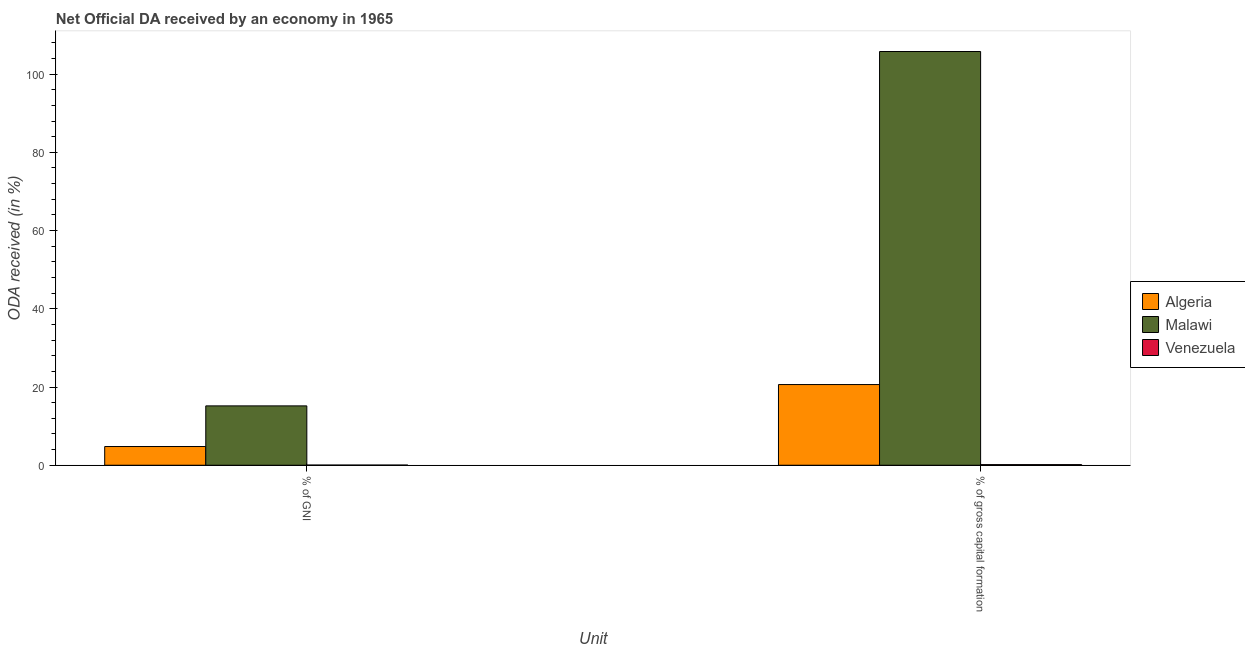Are the number of bars per tick equal to the number of legend labels?
Give a very brief answer. Yes. Are the number of bars on each tick of the X-axis equal?
Give a very brief answer. Yes. How many bars are there on the 2nd tick from the right?
Ensure brevity in your answer.  3. What is the label of the 1st group of bars from the left?
Ensure brevity in your answer.  % of GNI. What is the oda received as percentage of gni in Venezuela?
Your answer should be compact. 0.04. Across all countries, what is the maximum oda received as percentage of gni?
Offer a terse response. 15.18. Across all countries, what is the minimum oda received as percentage of gni?
Provide a short and direct response. 0.04. In which country was the oda received as percentage of gni maximum?
Your answer should be very brief. Malawi. In which country was the oda received as percentage of gross capital formation minimum?
Provide a succinct answer. Venezuela. What is the total oda received as percentage of gross capital formation in the graph?
Provide a short and direct response. 126.56. What is the difference between the oda received as percentage of gni in Algeria and that in Malawi?
Ensure brevity in your answer.  -10.39. What is the difference between the oda received as percentage of gni in Malawi and the oda received as percentage of gross capital formation in Venezuela?
Offer a very short reply. 15.02. What is the average oda received as percentage of gni per country?
Your response must be concise. 6.67. What is the difference between the oda received as percentage of gross capital formation and oda received as percentage of gni in Algeria?
Your response must be concise. 15.84. In how many countries, is the oda received as percentage of gni greater than 24 %?
Provide a short and direct response. 0. What is the ratio of the oda received as percentage of gni in Malawi to that in Venezuela?
Make the answer very short. 355.4. In how many countries, is the oda received as percentage of gni greater than the average oda received as percentage of gni taken over all countries?
Your answer should be very brief. 1. What does the 1st bar from the left in % of GNI represents?
Keep it short and to the point. Algeria. What does the 2nd bar from the right in % of gross capital formation represents?
Keep it short and to the point. Malawi. Are all the bars in the graph horizontal?
Provide a succinct answer. No. How many countries are there in the graph?
Provide a short and direct response. 3. How are the legend labels stacked?
Give a very brief answer. Vertical. What is the title of the graph?
Your answer should be very brief. Net Official DA received by an economy in 1965. What is the label or title of the X-axis?
Your answer should be compact. Unit. What is the label or title of the Y-axis?
Your answer should be very brief. ODA received (in %). What is the ODA received (in %) in Algeria in % of GNI?
Your answer should be very brief. 4.79. What is the ODA received (in %) in Malawi in % of GNI?
Provide a short and direct response. 15.18. What is the ODA received (in %) in Venezuela in % of GNI?
Your answer should be very brief. 0.04. What is the ODA received (in %) of Algeria in % of gross capital formation?
Offer a terse response. 20.63. What is the ODA received (in %) in Malawi in % of gross capital formation?
Give a very brief answer. 105.77. What is the ODA received (in %) of Venezuela in % of gross capital formation?
Give a very brief answer. 0.16. Across all Unit, what is the maximum ODA received (in %) of Algeria?
Give a very brief answer. 20.63. Across all Unit, what is the maximum ODA received (in %) of Malawi?
Provide a short and direct response. 105.77. Across all Unit, what is the maximum ODA received (in %) in Venezuela?
Provide a succinct answer. 0.16. Across all Unit, what is the minimum ODA received (in %) of Algeria?
Ensure brevity in your answer.  4.79. Across all Unit, what is the minimum ODA received (in %) of Malawi?
Keep it short and to the point. 15.18. Across all Unit, what is the minimum ODA received (in %) in Venezuela?
Your response must be concise. 0.04. What is the total ODA received (in %) of Algeria in the graph?
Your answer should be very brief. 25.41. What is the total ODA received (in %) in Malawi in the graph?
Make the answer very short. 120.95. What is the total ODA received (in %) in Venezuela in the graph?
Your answer should be very brief. 0.2. What is the difference between the ODA received (in %) of Algeria in % of GNI and that in % of gross capital formation?
Make the answer very short. -15.84. What is the difference between the ODA received (in %) in Malawi in % of GNI and that in % of gross capital formation?
Keep it short and to the point. -90.59. What is the difference between the ODA received (in %) of Venezuela in % of GNI and that in % of gross capital formation?
Ensure brevity in your answer.  -0.12. What is the difference between the ODA received (in %) of Algeria in % of GNI and the ODA received (in %) of Malawi in % of gross capital formation?
Make the answer very short. -100.98. What is the difference between the ODA received (in %) of Algeria in % of GNI and the ODA received (in %) of Venezuela in % of gross capital formation?
Offer a terse response. 4.63. What is the difference between the ODA received (in %) in Malawi in % of GNI and the ODA received (in %) in Venezuela in % of gross capital formation?
Offer a very short reply. 15.02. What is the average ODA received (in %) in Algeria per Unit?
Your answer should be compact. 12.71. What is the average ODA received (in %) in Malawi per Unit?
Keep it short and to the point. 60.47. What is the average ODA received (in %) in Venezuela per Unit?
Make the answer very short. 0.1. What is the difference between the ODA received (in %) of Algeria and ODA received (in %) of Malawi in % of GNI?
Provide a short and direct response. -10.39. What is the difference between the ODA received (in %) of Algeria and ODA received (in %) of Venezuela in % of GNI?
Keep it short and to the point. 4.74. What is the difference between the ODA received (in %) of Malawi and ODA received (in %) of Venezuela in % of GNI?
Your answer should be compact. 15.13. What is the difference between the ODA received (in %) of Algeria and ODA received (in %) of Malawi in % of gross capital formation?
Offer a very short reply. -85.14. What is the difference between the ODA received (in %) of Algeria and ODA received (in %) of Venezuela in % of gross capital formation?
Keep it short and to the point. 20.47. What is the difference between the ODA received (in %) in Malawi and ODA received (in %) in Venezuela in % of gross capital formation?
Offer a terse response. 105.61. What is the ratio of the ODA received (in %) of Algeria in % of GNI to that in % of gross capital formation?
Make the answer very short. 0.23. What is the ratio of the ODA received (in %) in Malawi in % of GNI to that in % of gross capital formation?
Provide a short and direct response. 0.14. What is the ratio of the ODA received (in %) of Venezuela in % of GNI to that in % of gross capital formation?
Ensure brevity in your answer.  0.27. What is the difference between the highest and the second highest ODA received (in %) in Algeria?
Make the answer very short. 15.84. What is the difference between the highest and the second highest ODA received (in %) in Malawi?
Your response must be concise. 90.59. What is the difference between the highest and the second highest ODA received (in %) in Venezuela?
Your answer should be compact. 0.12. What is the difference between the highest and the lowest ODA received (in %) of Algeria?
Give a very brief answer. 15.84. What is the difference between the highest and the lowest ODA received (in %) in Malawi?
Offer a very short reply. 90.59. What is the difference between the highest and the lowest ODA received (in %) of Venezuela?
Provide a succinct answer. 0.12. 